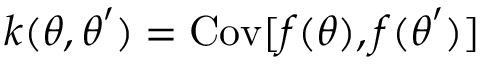<formula> <loc_0><loc_0><loc_500><loc_500>k ( \theta , \theta ^ { \prime } ) = C o v [ f ( \theta ) , f ( \theta ^ { \prime } ) ]</formula> 